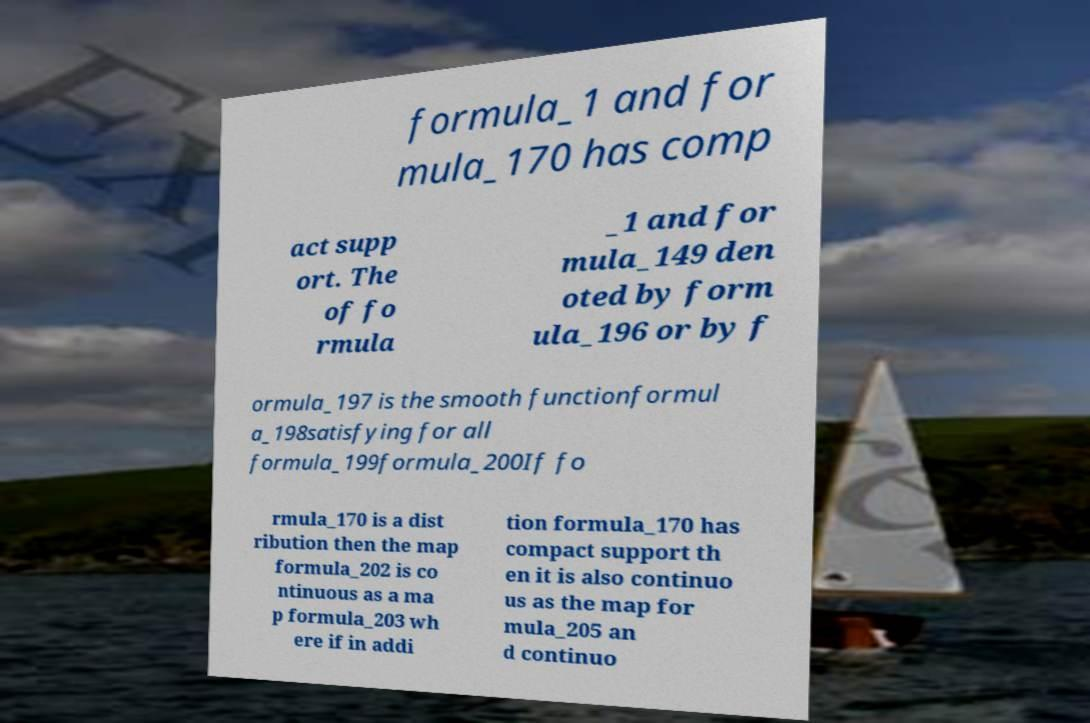Please identify and transcribe the text found in this image. formula_1 and for mula_170 has comp act supp ort. The of fo rmula _1 and for mula_149 den oted by form ula_196 or by f ormula_197 is the smooth functionformul a_198satisfying for all formula_199formula_200If fo rmula_170 is a dist ribution then the map formula_202 is co ntinuous as a ma p formula_203 wh ere if in addi tion formula_170 has compact support th en it is also continuo us as the map for mula_205 an d continuo 